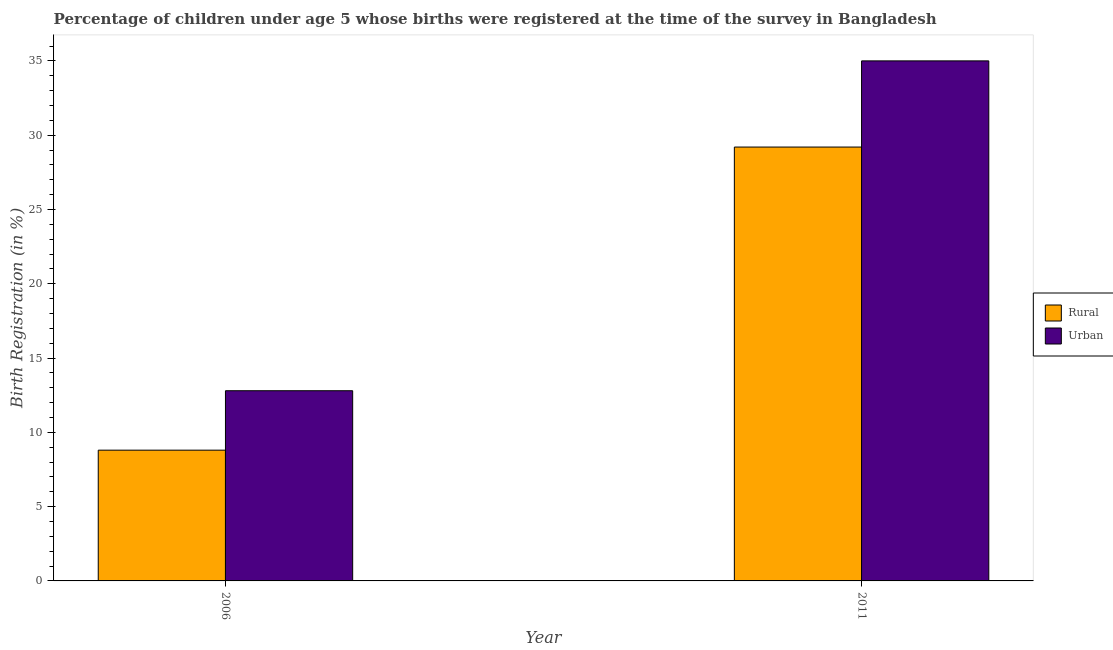Are the number of bars per tick equal to the number of legend labels?
Ensure brevity in your answer.  Yes. How many bars are there on the 2nd tick from the right?
Provide a succinct answer. 2. Across all years, what is the maximum urban birth registration?
Offer a very short reply. 35. Across all years, what is the minimum urban birth registration?
Make the answer very short. 12.8. In which year was the rural birth registration maximum?
Your response must be concise. 2011. In which year was the urban birth registration minimum?
Ensure brevity in your answer.  2006. What is the total urban birth registration in the graph?
Make the answer very short. 47.8. What is the difference between the rural birth registration in 2006 and that in 2011?
Provide a succinct answer. -20.4. What is the difference between the urban birth registration in 2011 and the rural birth registration in 2006?
Provide a short and direct response. 22.2. What is the average urban birth registration per year?
Your answer should be very brief. 23.9. In how many years, is the rural birth registration greater than 4 %?
Your answer should be very brief. 2. What is the ratio of the urban birth registration in 2006 to that in 2011?
Ensure brevity in your answer.  0.37. What does the 2nd bar from the left in 2011 represents?
Ensure brevity in your answer.  Urban. What does the 1st bar from the right in 2006 represents?
Ensure brevity in your answer.  Urban. How many bars are there?
Give a very brief answer. 4. Are all the bars in the graph horizontal?
Your answer should be very brief. No. How many years are there in the graph?
Make the answer very short. 2. What is the difference between two consecutive major ticks on the Y-axis?
Keep it short and to the point. 5. Does the graph contain any zero values?
Keep it short and to the point. No. Does the graph contain grids?
Provide a succinct answer. No. Where does the legend appear in the graph?
Provide a succinct answer. Center right. How many legend labels are there?
Provide a short and direct response. 2. How are the legend labels stacked?
Offer a terse response. Vertical. What is the title of the graph?
Your response must be concise. Percentage of children under age 5 whose births were registered at the time of the survey in Bangladesh. Does "Girls" appear as one of the legend labels in the graph?
Your response must be concise. No. What is the label or title of the Y-axis?
Make the answer very short. Birth Registration (in %). What is the Birth Registration (in %) in Rural in 2011?
Your answer should be compact. 29.2. Across all years, what is the maximum Birth Registration (in %) in Rural?
Provide a short and direct response. 29.2. Across all years, what is the minimum Birth Registration (in %) of Urban?
Offer a terse response. 12.8. What is the total Birth Registration (in %) of Rural in the graph?
Offer a very short reply. 38. What is the total Birth Registration (in %) of Urban in the graph?
Provide a succinct answer. 47.8. What is the difference between the Birth Registration (in %) in Rural in 2006 and that in 2011?
Keep it short and to the point. -20.4. What is the difference between the Birth Registration (in %) in Urban in 2006 and that in 2011?
Your answer should be compact. -22.2. What is the difference between the Birth Registration (in %) in Rural in 2006 and the Birth Registration (in %) in Urban in 2011?
Your response must be concise. -26.2. What is the average Birth Registration (in %) in Rural per year?
Provide a succinct answer. 19. What is the average Birth Registration (in %) in Urban per year?
Offer a terse response. 23.9. In the year 2006, what is the difference between the Birth Registration (in %) in Rural and Birth Registration (in %) in Urban?
Keep it short and to the point. -4. In the year 2011, what is the difference between the Birth Registration (in %) in Rural and Birth Registration (in %) in Urban?
Make the answer very short. -5.8. What is the ratio of the Birth Registration (in %) in Rural in 2006 to that in 2011?
Make the answer very short. 0.3. What is the ratio of the Birth Registration (in %) of Urban in 2006 to that in 2011?
Keep it short and to the point. 0.37. What is the difference between the highest and the second highest Birth Registration (in %) of Rural?
Your answer should be compact. 20.4. What is the difference between the highest and the second highest Birth Registration (in %) of Urban?
Offer a very short reply. 22.2. What is the difference between the highest and the lowest Birth Registration (in %) in Rural?
Provide a short and direct response. 20.4. What is the difference between the highest and the lowest Birth Registration (in %) in Urban?
Make the answer very short. 22.2. 